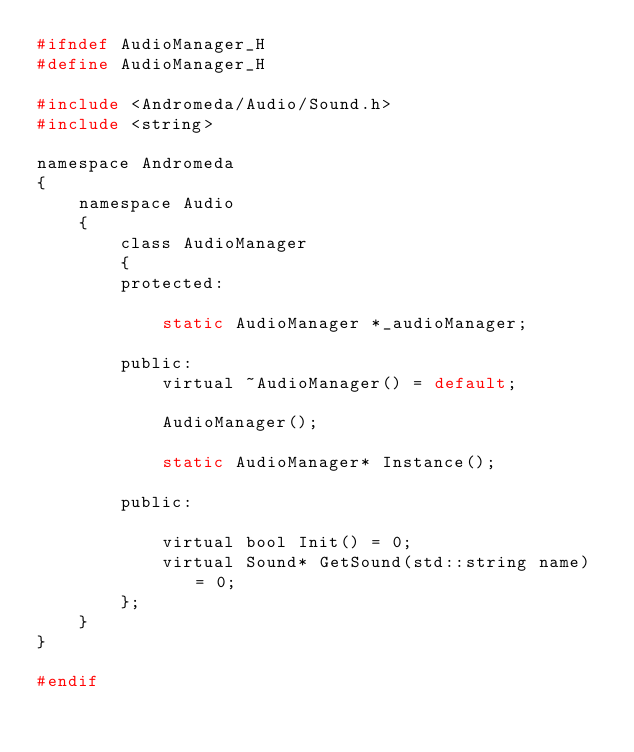Convert code to text. <code><loc_0><loc_0><loc_500><loc_500><_C_>#ifndef AudioManager_H
#define AudioManager_H

#include <Andromeda/Audio/Sound.h>
#include <string>

namespace Andromeda
{
	namespace Audio
	{
		class AudioManager
		{
		protected:

			static AudioManager *_audioManager;

		public:
            virtual ~AudioManager() = default;

            AudioManager();

			static AudioManager* Instance();

		public:

			virtual bool Init() = 0;
			virtual Sound* GetSound(std::string name) = 0;
		};
	}
}

#endif</code> 